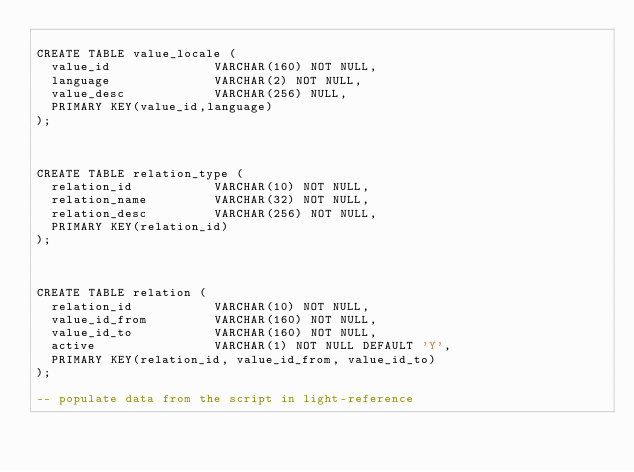Convert code to text. <code><loc_0><loc_0><loc_500><loc_500><_SQL_>
CREATE TABLE value_locale (
  value_id              VARCHAR(160) NOT NULL,
  language              VARCHAR(2) NOT NULL,
  value_desc            VARCHAR(256) NULL,
  PRIMARY KEY(value_id,language)
);



CREATE TABLE relation_type (
  relation_id           VARCHAR(10) NOT NULL,
  relation_name         VARCHAR(32) NOT NULL,
  relation_desc         VARCHAR(256) NOT NULL,
  PRIMARY KEY(relation_id)
);



CREATE TABLE relation (
  relation_id           VARCHAR(10) NOT NULL,
  value_id_from         VARCHAR(160) NOT NULL,
  value_id_to           VARCHAR(160) NOT NULL,
  active                VARCHAR(1) NOT NULL DEFAULT 'Y',
  PRIMARY KEY(relation_id, value_id_from, value_id_to)
);

-- populate data from the script in light-reference
</code> 